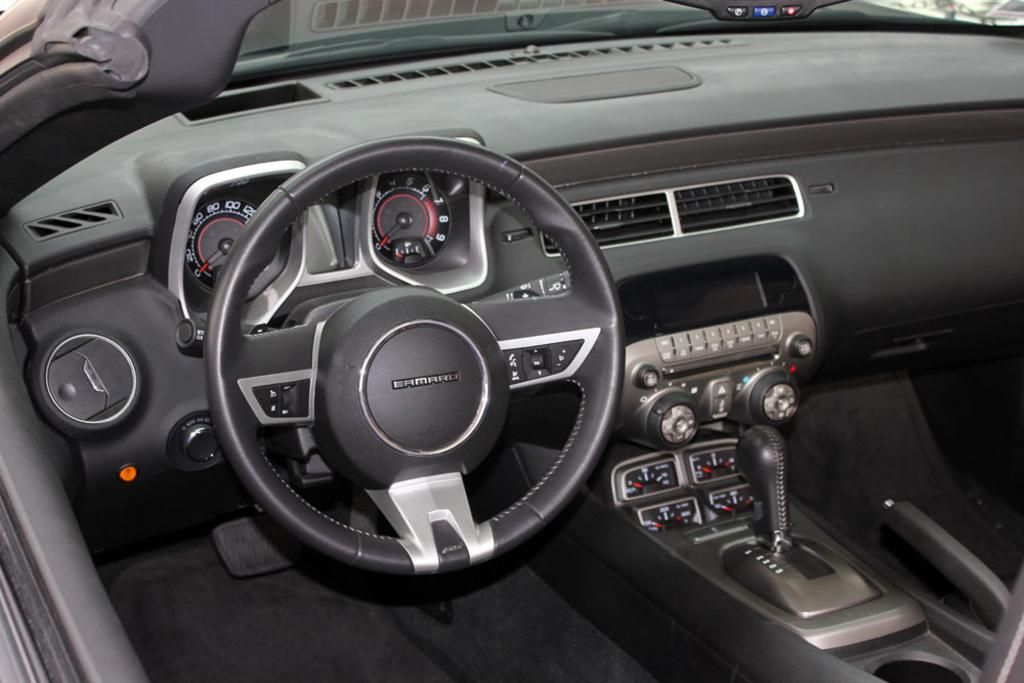What type of vehicle is shown in the image? The image is an inner view of a vehicle, but the specific type cannot be determined from the provided facts. What is the main control device in the vehicle? There is a steering wheel in the image. How can the driver monitor the speed of the vehicle? There are speedometers in the image. What device is present for entertainment or communication? There is a radio in the image. How does the driver change gears in the vehicle? There is a gear in the image. What allows the driver to see the road ahead? There is a front glass window in the image. Can you describe any other objects visible in the image? There are other objects visible in the image, but their specific nature cannot be determined from the provided facts. Where is the toad sitting in the image? There is no toad present in the image. What type of kettle is visible in the image? There is no kettle present in the image. 